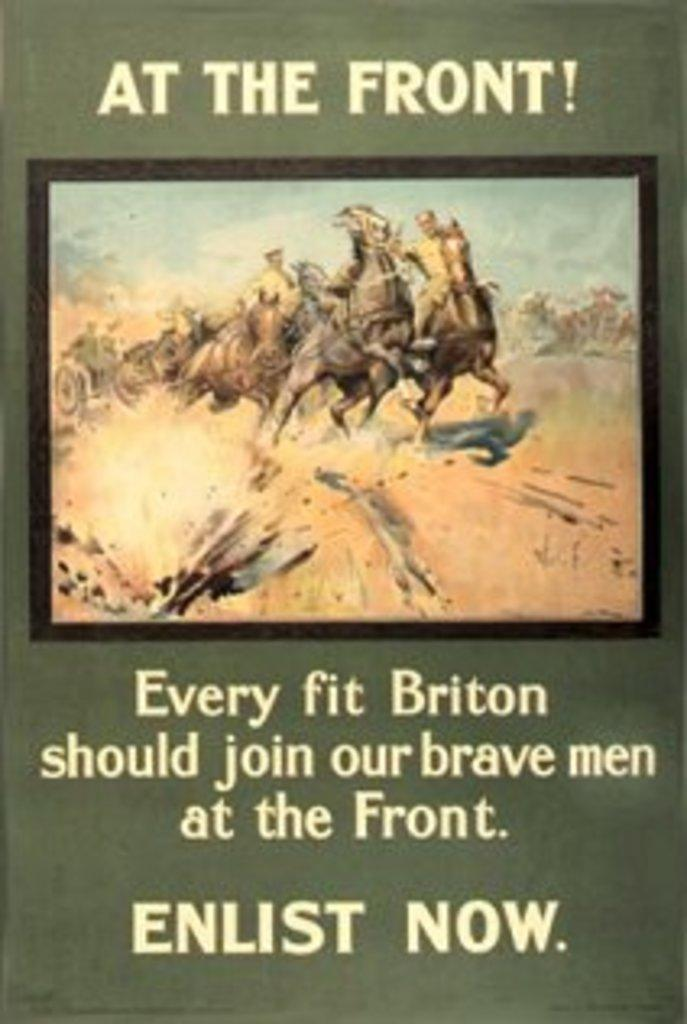<image>
Present a compact description of the photo's key features. A green poster showing soldiers riding horses says At the Front. 